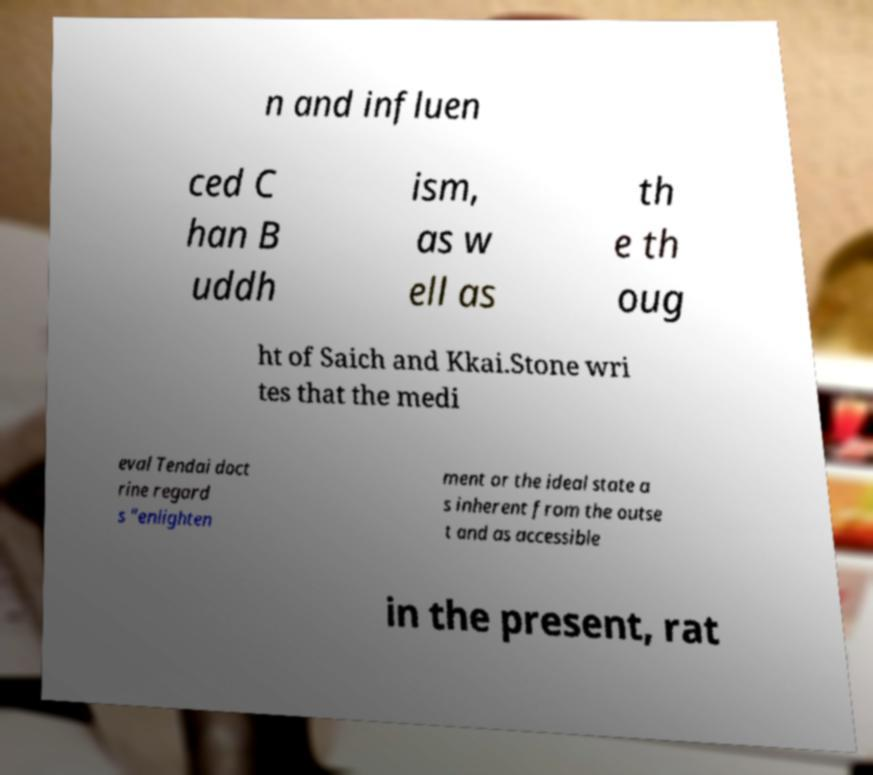What messages or text are displayed in this image? I need them in a readable, typed format. n and influen ced C han B uddh ism, as w ell as th e th oug ht of Saich and Kkai.Stone wri tes that the medi eval Tendai doct rine regard s "enlighten ment or the ideal state a s inherent from the outse t and as accessible in the present, rat 